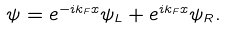Convert formula to latex. <formula><loc_0><loc_0><loc_500><loc_500>\psi = e ^ { - i k _ { F } x } \psi _ { L } + e ^ { i k _ { F } x } \psi _ { R } .</formula> 